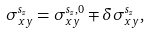<formula> <loc_0><loc_0><loc_500><loc_500>\sigma ^ { s _ { z } } _ { x y } = \sigma ^ { s _ { z } , 0 } _ { x y } \mp \delta \sigma ^ { s _ { z } } _ { x y } ,</formula> 